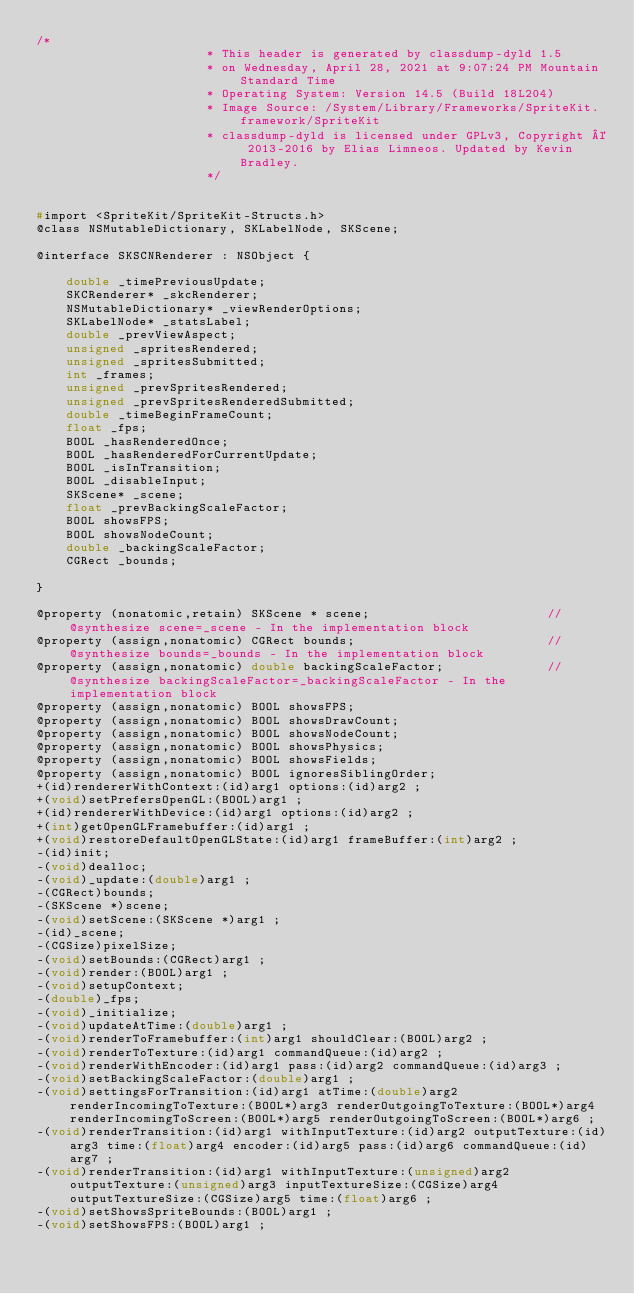Convert code to text. <code><loc_0><loc_0><loc_500><loc_500><_C_>/*
                       * This header is generated by classdump-dyld 1.5
                       * on Wednesday, April 28, 2021 at 9:07:24 PM Mountain Standard Time
                       * Operating System: Version 14.5 (Build 18L204)
                       * Image Source: /System/Library/Frameworks/SpriteKit.framework/SpriteKit
                       * classdump-dyld is licensed under GPLv3, Copyright © 2013-2016 by Elias Limneos. Updated by Kevin Bradley.
                       */


#import <SpriteKit/SpriteKit-Structs.h>
@class NSMutableDictionary, SKLabelNode, SKScene;

@interface SKSCNRenderer : NSObject {

	double _timePreviousUpdate;
	SKCRenderer* _skcRenderer;
	NSMutableDictionary* _viewRenderOptions;
	SKLabelNode* _statsLabel;
	double _prevViewAspect;
	unsigned _spritesRendered;
	unsigned _spritesSubmitted;
	int _frames;
	unsigned _prevSpritesRendered;
	unsigned _prevSpritesRenderedSubmitted;
	double _timeBeginFrameCount;
	float _fps;
	BOOL _hasRenderedOnce;
	BOOL _hasRenderedForCurrentUpdate;
	BOOL _isInTransition;
	BOOL _disableInput;
	SKScene* _scene;
	float _prevBackingScaleFactor;
	BOOL showsFPS;
	BOOL showsNodeCount;
	double _backingScaleFactor;
	CGRect _bounds;

}

@property (nonatomic,retain) SKScene * scene;                        //@synthesize scene=_scene - In the implementation block
@property (assign,nonatomic) CGRect bounds;                          //@synthesize bounds=_bounds - In the implementation block
@property (assign,nonatomic) double backingScaleFactor;              //@synthesize backingScaleFactor=_backingScaleFactor - In the implementation block
@property (assign,nonatomic) BOOL showsFPS; 
@property (assign,nonatomic) BOOL showsDrawCount; 
@property (assign,nonatomic) BOOL showsNodeCount; 
@property (assign,nonatomic) BOOL showsPhysics; 
@property (assign,nonatomic) BOOL showsFields; 
@property (assign,nonatomic) BOOL ignoresSiblingOrder; 
+(id)rendererWithContext:(id)arg1 options:(id)arg2 ;
+(void)setPrefersOpenGL:(BOOL)arg1 ;
+(id)rendererWithDevice:(id)arg1 options:(id)arg2 ;
+(int)getOpenGLFramebuffer:(id)arg1 ;
+(void)restoreDefaultOpenGLState:(id)arg1 frameBuffer:(int)arg2 ;
-(id)init;
-(void)dealloc;
-(void)_update:(double)arg1 ;
-(CGRect)bounds;
-(SKScene *)scene;
-(void)setScene:(SKScene *)arg1 ;
-(id)_scene;
-(CGSize)pixelSize;
-(void)setBounds:(CGRect)arg1 ;
-(void)render:(BOOL)arg1 ;
-(void)setupContext;
-(double)_fps;
-(void)_initialize;
-(void)updateAtTime:(double)arg1 ;
-(void)renderToFramebuffer:(int)arg1 shouldClear:(BOOL)arg2 ;
-(void)renderToTexture:(id)arg1 commandQueue:(id)arg2 ;
-(void)renderWithEncoder:(id)arg1 pass:(id)arg2 commandQueue:(id)arg3 ;
-(void)setBackingScaleFactor:(double)arg1 ;
-(void)settingsForTransition:(id)arg1 atTime:(double)arg2 renderIncomingToTexture:(BOOL*)arg3 renderOutgoingToTexture:(BOOL*)arg4 renderIncomingToScreen:(BOOL*)arg5 renderOutgoingToScreen:(BOOL*)arg6 ;
-(void)renderTransition:(id)arg1 withInputTexture:(id)arg2 outputTexture:(id)arg3 time:(float)arg4 encoder:(id)arg5 pass:(id)arg6 commandQueue:(id)arg7 ;
-(void)renderTransition:(id)arg1 withInputTexture:(unsigned)arg2 outputTexture:(unsigned)arg3 inputTextureSize:(CGSize)arg4 outputTextureSize:(CGSize)arg5 time:(float)arg6 ;
-(void)setShowsSpriteBounds:(BOOL)arg1 ;
-(void)setShowsFPS:(BOOL)arg1 ;</code> 